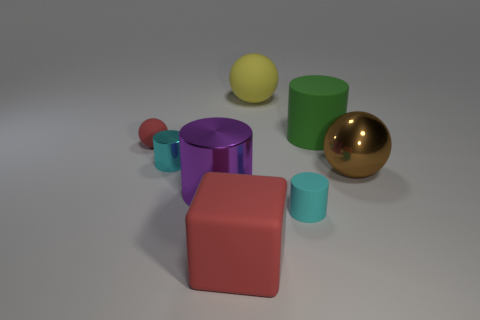Subtract 1 cylinders. How many cylinders are left? 3 Add 1 large brown metallic spheres. How many objects exist? 9 Subtract all spheres. How many objects are left? 5 Add 1 rubber spheres. How many rubber spheres are left? 3 Add 1 green matte cylinders. How many green matte cylinders exist? 2 Subtract 0 green spheres. How many objects are left? 8 Subtract all tiny yellow metal objects. Subtract all big yellow rubber things. How many objects are left? 7 